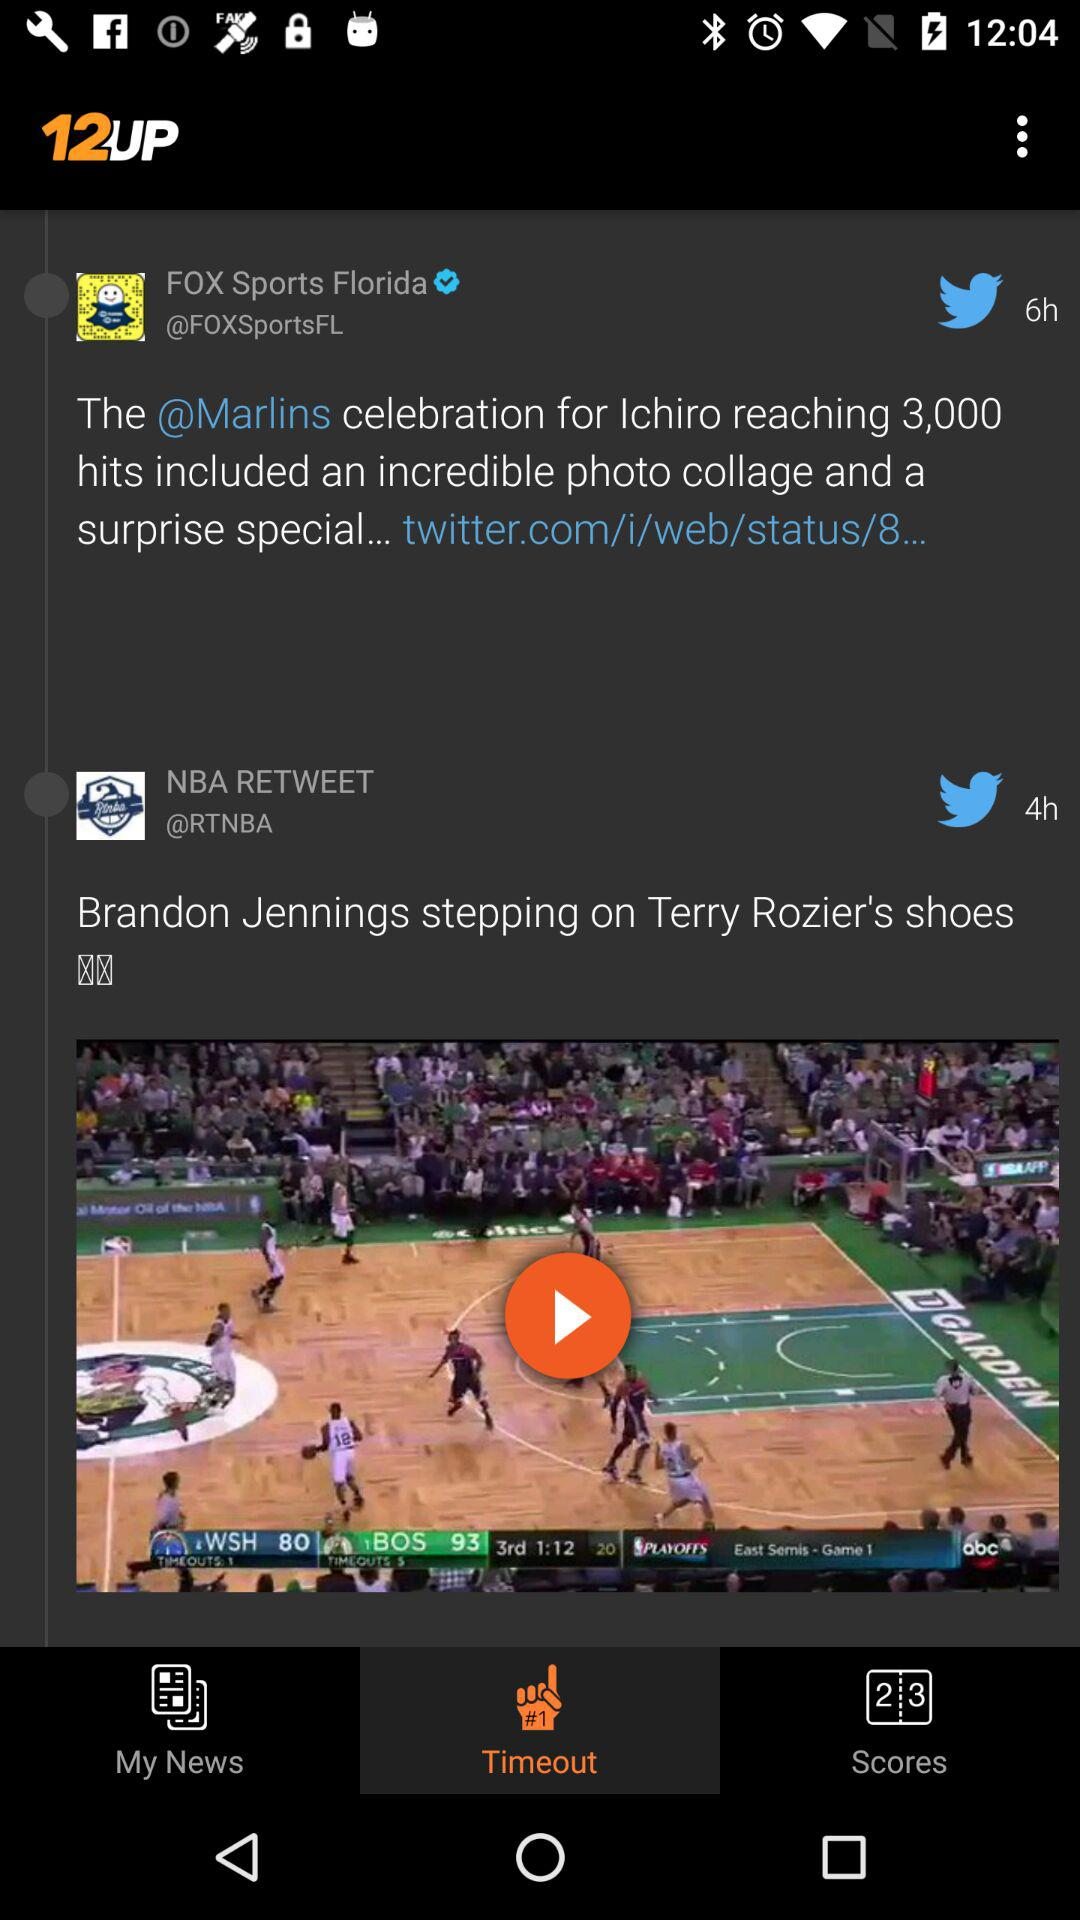Which option is selected in the application? The selected option is "Timeout". 